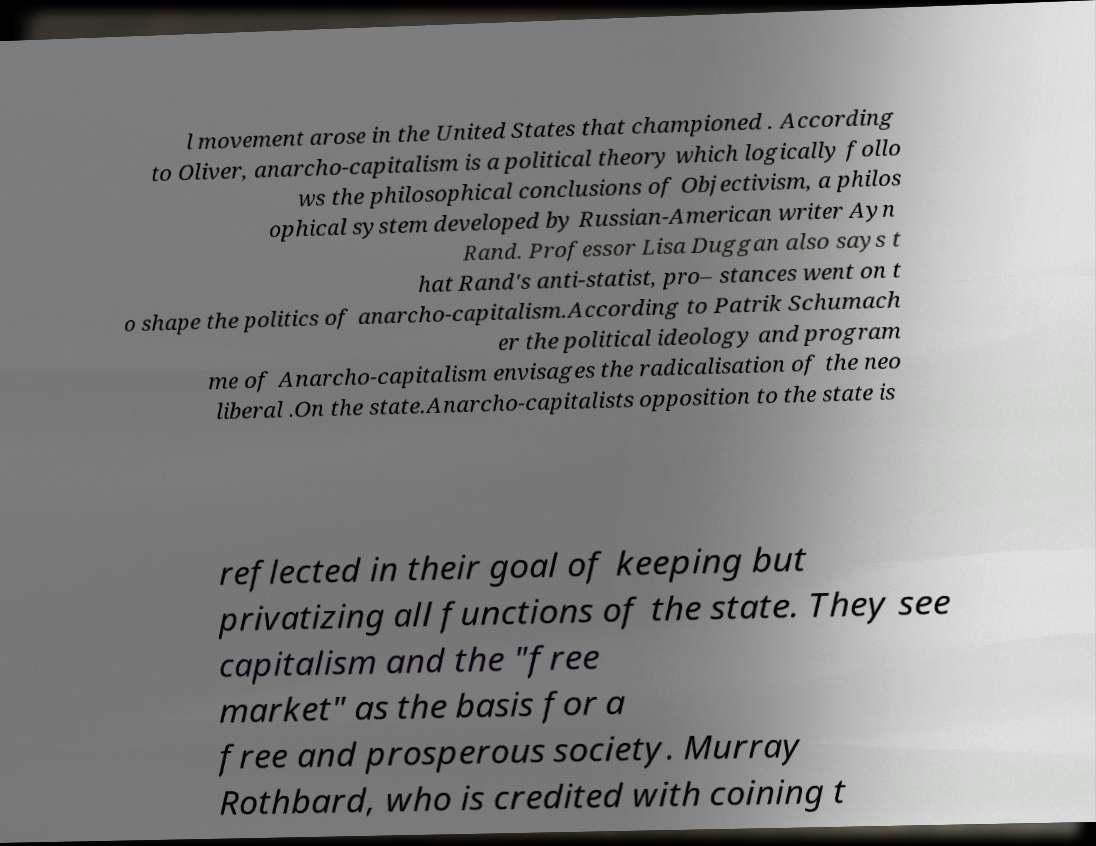Please read and relay the text visible in this image. What does it say? l movement arose in the United States that championed . According to Oliver, anarcho-capitalism is a political theory which logically follo ws the philosophical conclusions of Objectivism, a philos ophical system developed by Russian-American writer Ayn Rand. Professor Lisa Duggan also says t hat Rand's anti-statist, pro– stances went on t o shape the politics of anarcho-capitalism.According to Patrik Schumach er the political ideology and program me of Anarcho-capitalism envisages the radicalisation of the neo liberal .On the state.Anarcho-capitalists opposition to the state is reflected in their goal of keeping but privatizing all functions of the state. They see capitalism and the "free market" as the basis for a free and prosperous society. Murray Rothbard, who is credited with coining t 